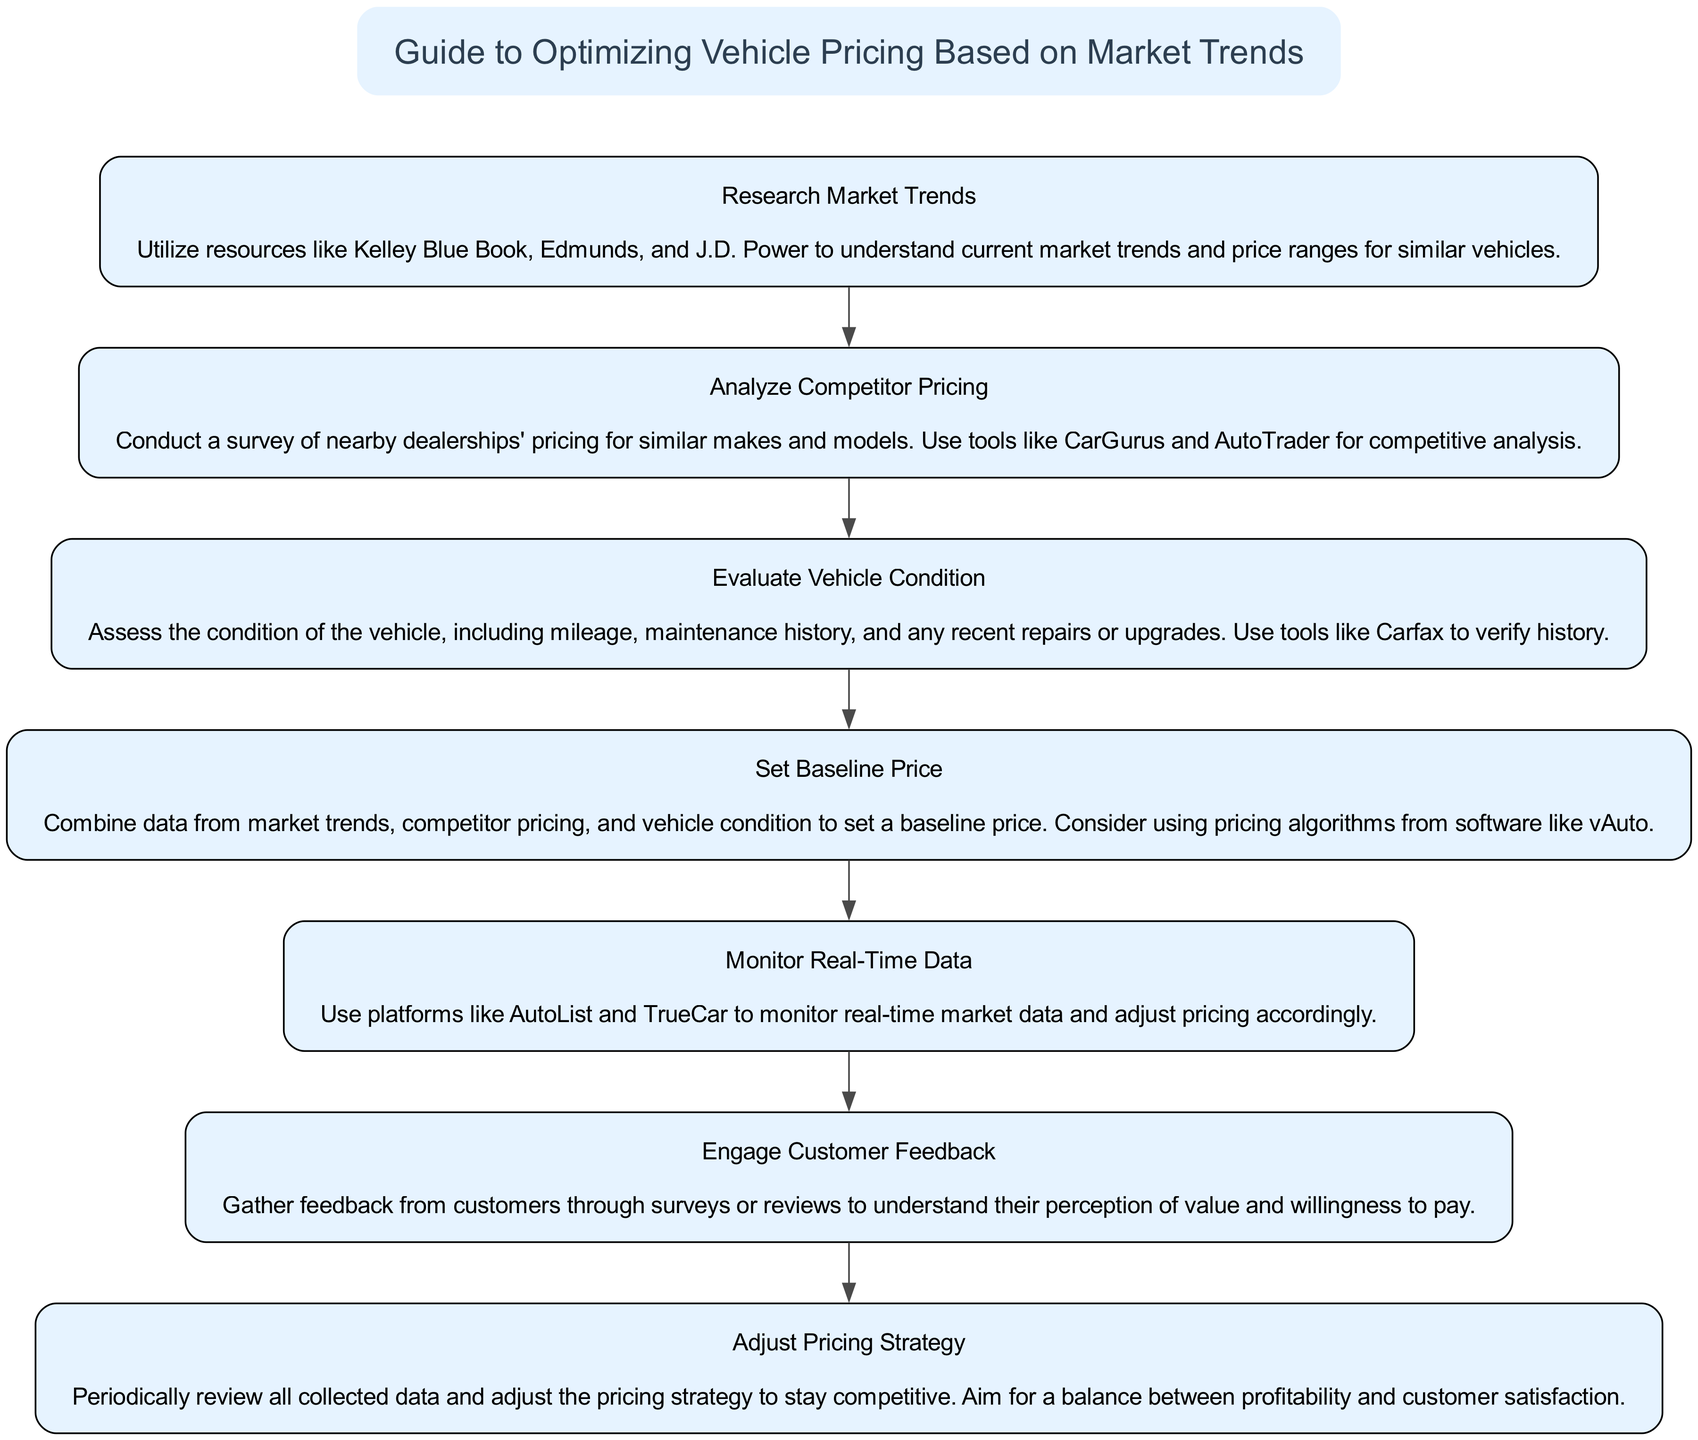What is the title of the diagram? The title of the diagram is found at the top node, which clearly states "Guide to Optimizing Vehicle Pricing Based on Market Trends."
Answer: Guide to Optimizing Vehicle Pricing Based on Market Trends How many steps are included in the flow chart? There are seven steps in total, as indicated by the number of nodes representing each step in the flow chart.
Answer: 7 What is the first step of the process? The first step is represented by the node connected to the title, which is "Research Market Trends."
Answer: Research Market Trends Which step follows "Set Baseline Price"? The step that follows "Set Baseline Price" is "Monitor Real-Time Data," as indicated by the directed edge connecting these two steps in the flow.
Answer: Monitor Real-Time Data What tools are suggested for analyzing competitor pricing? The tools suggested for analyzing competitor pricing are mentioned in the description of "Analyze Competitor Pricing," which includes CarGurus and AutoTrader.
Answer: CarGurus and AutoTrader What should be done after gathering customer feedback? After gathering customer feedback, the next action is to "Adjust Pricing Strategy," as indicated by the directed flow from the customer feedback step to this next action in the diagram.
Answer: Adjust Pricing Strategy What are the three factors combined to set the baseline price? The three factors combined to set the baseline price are market trends, competitor pricing, and vehicle condition, as specified in the description of "Set Baseline Price."
Answer: Market trends, competitor pricing, and vehicle condition How does customer feedback influence the pricing strategy? Customer feedback influences the pricing strategy as it is collected and reviewed, leading to periodic adjustments to ensure competitiveness and customer satisfaction, as indicated in the "Adjust Pricing Strategy" step.
Answer: Periodic adjustments What tool is recommended for assessing vehicle condition? The tool recommended for assessing vehicle condition, specifically for verifying history, is Carfax, as mentioned in the "Evaluate Vehicle Condition" step.
Answer: Carfax 